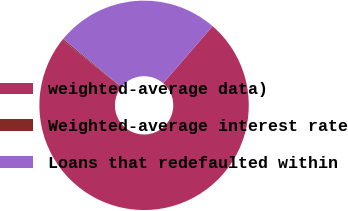Convert chart. <chart><loc_0><loc_0><loc_500><loc_500><pie_chart><fcel>weighted-average data)<fcel>Weighted-average interest rate<fcel>Loans that redefaulted within<nl><fcel>74.39%<fcel>0.2%<fcel>25.41%<nl></chart> 